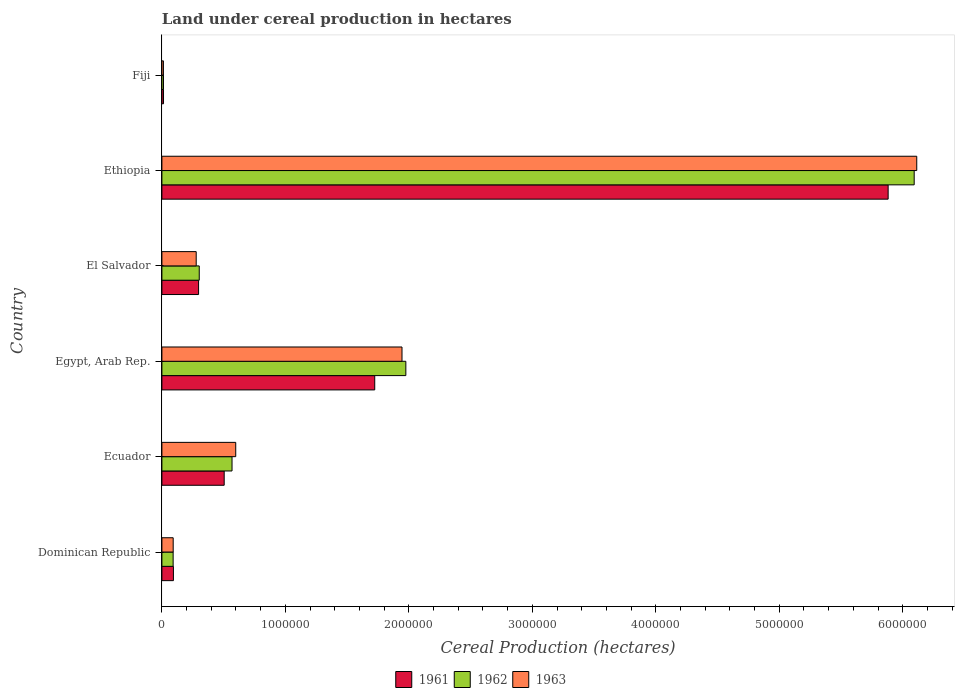How many different coloured bars are there?
Keep it short and to the point. 3. Are the number of bars per tick equal to the number of legend labels?
Make the answer very short. Yes. Are the number of bars on each tick of the Y-axis equal?
Offer a terse response. Yes. What is the label of the 5th group of bars from the top?
Keep it short and to the point. Ecuador. What is the land under cereal production in 1963 in Ecuador?
Offer a terse response. 5.98e+05. Across all countries, what is the maximum land under cereal production in 1962?
Your response must be concise. 6.09e+06. Across all countries, what is the minimum land under cereal production in 1961?
Ensure brevity in your answer.  1.31e+04. In which country was the land under cereal production in 1963 maximum?
Your answer should be compact. Ethiopia. In which country was the land under cereal production in 1961 minimum?
Give a very brief answer. Fiji. What is the total land under cereal production in 1962 in the graph?
Make the answer very short. 9.04e+06. What is the difference between the land under cereal production in 1962 in Egypt, Arab Rep. and that in Fiji?
Provide a succinct answer. 1.96e+06. What is the difference between the land under cereal production in 1962 in El Salvador and the land under cereal production in 1961 in Egypt, Arab Rep.?
Make the answer very short. -1.42e+06. What is the average land under cereal production in 1963 per country?
Offer a terse response. 1.51e+06. What is the difference between the land under cereal production in 1962 and land under cereal production in 1963 in Fiji?
Offer a terse response. 594. What is the ratio of the land under cereal production in 1963 in Ecuador to that in Fiji?
Keep it short and to the point. 48.77. Is the difference between the land under cereal production in 1962 in El Salvador and Ethiopia greater than the difference between the land under cereal production in 1963 in El Salvador and Ethiopia?
Your answer should be compact. Yes. What is the difference between the highest and the second highest land under cereal production in 1962?
Make the answer very short. 4.12e+06. What is the difference between the highest and the lowest land under cereal production in 1962?
Your answer should be compact. 6.08e+06. Is the sum of the land under cereal production in 1963 in Dominican Republic and Ecuador greater than the maximum land under cereal production in 1961 across all countries?
Make the answer very short. No. What does the 3rd bar from the bottom in Dominican Republic represents?
Offer a very short reply. 1963. Are all the bars in the graph horizontal?
Offer a terse response. Yes. Does the graph contain grids?
Ensure brevity in your answer.  No. How are the legend labels stacked?
Keep it short and to the point. Horizontal. What is the title of the graph?
Offer a terse response. Land under cereal production in hectares. What is the label or title of the X-axis?
Make the answer very short. Cereal Production (hectares). What is the Cereal Production (hectares) in 1961 in Dominican Republic?
Offer a very short reply. 9.33e+04. What is the Cereal Production (hectares) of 1962 in Dominican Republic?
Your response must be concise. 9.10e+04. What is the Cereal Production (hectares) in 1963 in Dominican Republic?
Offer a very short reply. 9.14e+04. What is the Cereal Production (hectares) in 1961 in Ecuador?
Ensure brevity in your answer.  5.05e+05. What is the Cereal Production (hectares) in 1962 in Ecuador?
Offer a very short reply. 5.68e+05. What is the Cereal Production (hectares) in 1963 in Ecuador?
Offer a terse response. 5.98e+05. What is the Cereal Production (hectares) of 1961 in Egypt, Arab Rep.?
Your answer should be very brief. 1.72e+06. What is the Cereal Production (hectares) of 1962 in Egypt, Arab Rep.?
Your answer should be compact. 1.98e+06. What is the Cereal Production (hectares) in 1963 in Egypt, Arab Rep.?
Your answer should be compact. 1.94e+06. What is the Cereal Production (hectares) of 1961 in El Salvador?
Give a very brief answer. 2.97e+05. What is the Cereal Production (hectares) in 1962 in El Salvador?
Your response must be concise. 3.02e+05. What is the Cereal Production (hectares) in 1963 in El Salvador?
Give a very brief answer. 2.78e+05. What is the Cereal Production (hectares) in 1961 in Ethiopia?
Make the answer very short. 5.88e+06. What is the Cereal Production (hectares) of 1962 in Ethiopia?
Keep it short and to the point. 6.09e+06. What is the Cereal Production (hectares) of 1963 in Ethiopia?
Make the answer very short. 6.11e+06. What is the Cereal Production (hectares) of 1961 in Fiji?
Provide a short and direct response. 1.31e+04. What is the Cereal Production (hectares) of 1962 in Fiji?
Provide a succinct answer. 1.29e+04. What is the Cereal Production (hectares) of 1963 in Fiji?
Make the answer very short. 1.23e+04. Across all countries, what is the maximum Cereal Production (hectares) of 1961?
Your answer should be compact. 5.88e+06. Across all countries, what is the maximum Cereal Production (hectares) in 1962?
Keep it short and to the point. 6.09e+06. Across all countries, what is the maximum Cereal Production (hectares) in 1963?
Make the answer very short. 6.11e+06. Across all countries, what is the minimum Cereal Production (hectares) of 1961?
Provide a succinct answer. 1.31e+04. Across all countries, what is the minimum Cereal Production (hectares) in 1962?
Your answer should be compact. 1.29e+04. Across all countries, what is the minimum Cereal Production (hectares) in 1963?
Keep it short and to the point. 1.23e+04. What is the total Cereal Production (hectares) in 1961 in the graph?
Your answer should be compact. 8.51e+06. What is the total Cereal Production (hectares) of 1962 in the graph?
Provide a short and direct response. 9.04e+06. What is the total Cereal Production (hectares) in 1963 in the graph?
Offer a terse response. 9.04e+06. What is the difference between the Cereal Production (hectares) of 1961 in Dominican Republic and that in Ecuador?
Offer a very short reply. -4.11e+05. What is the difference between the Cereal Production (hectares) of 1962 in Dominican Republic and that in Ecuador?
Offer a very short reply. -4.77e+05. What is the difference between the Cereal Production (hectares) of 1963 in Dominican Republic and that in Ecuador?
Offer a very short reply. -5.07e+05. What is the difference between the Cereal Production (hectares) in 1961 in Dominican Republic and that in Egypt, Arab Rep.?
Your answer should be compact. -1.63e+06. What is the difference between the Cereal Production (hectares) of 1962 in Dominican Republic and that in Egypt, Arab Rep.?
Your answer should be very brief. -1.88e+06. What is the difference between the Cereal Production (hectares) in 1963 in Dominican Republic and that in Egypt, Arab Rep.?
Your response must be concise. -1.85e+06. What is the difference between the Cereal Production (hectares) of 1961 in Dominican Republic and that in El Salvador?
Your answer should be compact. -2.04e+05. What is the difference between the Cereal Production (hectares) in 1962 in Dominican Republic and that in El Salvador?
Your answer should be very brief. -2.11e+05. What is the difference between the Cereal Production (hectares) in 1963 in Dominican Republic and that in El Salvador?
Offer a terse response. -1.86e+05. What is the difference between the Cereal Production (hectares) in 1961 in Dominican Republic and that in Ethiopia?
Give a very brief answer. -5.79e+06. What is the difference between the Cereal Production (hectares) of 1962 in Dominican Republic and that in Ethiopia?
Your response must be concise. -6.00e+06. What is the difference between the Cereal Production (hectares) of 1963 in Dominican Republic and that in Ethiopia?
Offer a terse response. -6.02e+06. What is the difference between the Cereal Production (hectares) of 1961 in Dominican Republic and that in Fiji?
Your answer should be very brief. 8.03e+04. What is the difference between the Cereal Production (hectares) in 1962 in Dominican Republic and that in Fiji?
Your response must be concise. 7.81e+04. What is the difference between the Cereal Production (hectares) in 1963 in Dominican Republic and that in Fiji?
Your answer should be very brief. 7.91e+04. What is the difference between the Cereal Production (hectares) of 1961 in Ecuador and that in Egypt, Arab Rep.?
Provide a short and direct response. -1.22e+06. What is the difference between the Cereal Production (hectares) in 1962 in Ecuador and that in Egypt, Arab Rep.?
Offer a terse response. -1.41e+06. What is the difference between the Cereal Production (hectares) in 1963 in Ecuador and that in Egypt, Arab Rep.?
Make the answer very short. -1.35e+06. What is the difference between the Cereal Production (hectares) of 1961 in Ecuador and that in El Salvador?
Offer a terse response. 2.07e+05. What is the difference between the Cereal Production (hectares) of 1962 in Ecuador and that in El Salvador?
Offer a very short reply. 2.66e+05. What is the difference between the Cereal Production (hectares) in 1963 in Ecuador and that in El Salvador?
Provide a succinct answer. 3.20e+05. What is the difference between the Cereal Production (hectares) of 1961 in Ecuador and that in Ethiopia?
Make the answer very short. -5.38e+06. What is the difference between the Cereal Production (hectares) in 1962 in Ecuador and that in Ethiopia?
Ensure brevity in your answer.  -5.53e+06. What is the difference between the Cereal Production (hectares) in 1963 in Ecuador and that in Ethiopia?
Your response must be concise. -5.52e+06. What is the difference between the Cereal Production (hectares) in 1961 in Ecuador and that in Fiji?
Keep it short and to the point. 4.91e+05. What is the difference between the Cereal Production (hectares) of 1962 in Ecuador and that in Fiji?
Ensure brevity in your answer.  5.55e+05. What is the difference between the Cereal Production (hectares) in 1963 in Ecuador and that in Fiji?
Keep it short and to the point. 5.86e+05. What is the difference between the Cereal Production (hectares) in 1961 in Egypt, Arab Rep. and that in El Salvador?
Offer a terse response. 1.43e+06. What is the difference between the Cereal Production (hectares) of 1962 in Egypt, Arab Rep. and that in El Salvador?
Your answer should be very brief. 1.67e+06. What is the difference between the Cereal Production (hectares) in 1963 in Egypt, Arab Rep. and that in El Salvador?
Ensure brevity in your answer.  1.67e+06. What is the difference between the Cereal Production (hectares) in 1961 in Egypt, Arab Rep. and that in Ethiopia?
Make the answer very short. -4.16e+06. What is the difference between the Cereal Production (hectares) of 1962 in Egypt, Arab Rep. and that in Ethiopia?
Provide a succinct answer. -4.12e+06. What is the difference between the Cereal Production (hectares) of 1963 in Egypt, Arab Rep. and that in Ethiopia?
Keep it short and to the point. -4.17e+06. What is the difference between the Cereal Production (hectares) of 1961 in Egypt, Arab Rep. and that in Fiji?
Your answer should be compact. 1.71e+06. What is the difference between the Cereal Production (hectares) of 1962 in Egypt, Arab Rep. and that in Fiji?
Keep it short and to the point. 1.96e+06. What is the difference between the Cereal Production (hectares) in 1963 in Egypt, Arab Rep. and that in Fiji?
Offer a very short reply. 1.93e+06. What is the difference between the Cereal Production (hectares) of 1961 in El Salvador and that in Ethiopia?
Offer a very short reply. -5.58e+06. What is the difference between the Cereal Production (hectares) in 1962 in El Salvador and that in Ethiopia?
Your answer should be very brief. -5.79e+06. What is the difference between the Cereal Production (hectares) in 1963 in El Salvador and that in Ethiopia?
Your response must be concise. -5.84e+06. What is the difference between the Cereal Production (hectares) of 1961 in El Salvador and that in Fiji?
Offer a terse response. 2.84e+05. What is the difference between the Cereal Production (hectares) of 1962 in El Salvador and that in Fiji?
Keep it short and to the point. 2.90e+05. What is the difference between the Cereal Production (hectares) of 1963 in El Salvador and that in Fiji?
Keep it short and to the point. 2.66e+05. What is the difference between the Cereal Production (hectares) of 1961 in Ethiopia and that in Fiji?
Your answer should be compact. 5.87e+06. What is the difference between the Cereal Production (hectares) of 1962 in Ethiopia and that in Fiji?
Give a very brief answer. 6.08e+06. What is the difference between the Cereal Production (hectares) in 1963 in Ethiopia and that in Fiji?
Keep it short and to the point. 6.10e+06. What is the difference between the Cereal Production (hectares) of 1961 in Dominican Republic and the Cereal Production (hectares) of 1962 in Ecuador?
Ensure brevity in your answer.  -4.75e+05. What is the difference between the Cereal Production (hectares) of 1961 in Dominican Republic and the Cereal Production (hectares) of 1963 in Ecuador?
Ensure brevity in your answer.  -5.05e+05. What is the difference between the Cereal Production (hectares) in 1962 in Dominican Republic and the Cereal Production (hectares) in 1963 in Ecuador?
Provide a succinct answer. -5.07e+05. What is the difference between the Cereal Production (hectares) in 1961 in Dominican Republic and the Cereal Production (hectares) in 1962 in Egypt, Arab Rep.?
Keep it short and to the point. -1.88e+06. What is the difference between the Cereal Production (hectares) in 1961 in Dominican Republic and the Cereal Production (hectares) in 1963 in Egypt, Arab Rep.?
Your response must be concise. -1.85e+06. What is the difference between the Cereal Production (hectares) in 1962 in Dominican Republic and the Cereal Production (hectares) in 1963 in Egypt, Arab Rep.?
Provide a short and direct response. -1.85e+06. What is the difference between the Cereal Production (hectares) of 1961 in Dominican Republic and the Cereal Production (hectares) of 1962 in El Salvador?
Your answer should be very brief. -2.09e+05. What is the difference between the Cereal Production (hectares) of 1961 in Dominican Republic and the Cereal Production (hectares) of 1963 in El Salvador?
Give a very brief answer. -1.85e+05. What is the difference between the Cereal Production (hectares) in 1962 in Dominican Republic and the Cereal Production (hectares) in 1963 in El Salvador?
Your answer should be compact. -1.87e+05. What is the difference between the Cereal Production (hectares) in 1961 in Dominican Republic and the Cereal Production (hectares) in 1962 in Ethiopia?
Make the answer very short. -6.00e+06. What is the difference between the Cereal Production (hectares) of 1961 in Dominican Republic and the Cereal Production (hectares) of 1963 in Ethiopia?
Your answer should be compact. -6.02e+06. What is the difference between the Cereal Production (hectares) of 1962 in Dominican Republic and the Cereal Production (hectares) of 1963 in Ethiopia?
Offer a very short reply. -6.02e+06. What is the difference between the Cereal Production (hectares) in 1961 in Dominican Republic and the Cereal Production (hectares) in 1962 in Fiji?
Your answer should be very brief. 8.05e+04. What is the difference between the Cereal Production (hectares) in 1961 in Dominican Republic and the Cereal Production (hectares) in 1963 in Fiji?
Keep it short and to the point. 8.11e+04. What is the difference between the Cereal Production (hectares) in 1962 in Dominican Republic and the Cereal Production (hectares) in 1963 in Fiji?
Make the answer very short. 7.87e+04. What is the difference between the Cereal Production (hectares) in 1961 in Ecuador and the Cereal Production (hectares) in 1962 in Egypt, Arab Rep.?
Make the answer very short. -1.47e+06. What is the difference between the Cereal Production (hectares) of 1961 in Ecuador and the Cereal Production (hectares) of 1963 in Egypt, Arab Rep.?
Provide a short and direct response. -1.44e+06. What is the difference between the Cereal Production (hectares) of 1962 in Ecuador and the Cereal Production (hectares) of 1963 in Egypt, Arab Rep.?
Provide a succinct answer. -1.38e+06. What is the difference between the Cereal Production (hectares) of 1961 in Ecuador and the Cereal Production (hectares) of 1962 in El Salvador?
Provide a succinct answer. 2.02e+05. What is the difference between the Cereal Production (hectares) in 1961 in Ecuador and the Cereal Production (hectares) in 1963 in El Salvador?
Give a very brief answer. 2.27e+05. What is the difference between the Cereal Production (hectares) in 1962 in Ecuador and the Cereal Production (hectares) in 1963 in El Salvador?
Your answer should be compact. 2.90e+05. What is the difference between the Cereal Production (hectares) in 1961 in Ecuador and the Cereal Production (hectares) in 1962 in Ethiopia?
Offer a terse response. -5.59e+06. What is the difference between the Cereal Production (hectares) in 1961 in Ecuador and the Cereal Production (hectares) in 1963 in Ethiopia?
Offer a very short reply. -5.61e+06. What is the difference between the Cereal Production (hectares) in 1962 in Ecuador and the Cereal Production (hectares) in 1963 in Ethiopia?
Offer a terse response. -5.55e+06. What is the difference between the Cereal Production (hectares) in 1961 in Ecuador and the Cereal Production (hectares) in 1962 in Fiji?
Keep it short and to the point. 4.92e+05. What is the difference between the Cereal Production (hectares) in 1961 in Ecuador and the Cereal Production (hectares) in 1963 in Fiji?
Ensure brevity in your answer.  4.92e+05. What is the difference between the Cereal Production (hectares) of 1962 in Ecuador and the Cereal Production (hectares) of 1963 in Fiji?
Offer a very short reply. 5.56e+05. What is the difference between the Cereal Production (hectares) of 1961 in Egypt, Arab Rep. and the Cereal Production (hectares) of 1962 in El Salvador?
Offer a terse response. 1.42e+06. What is the difference between the Cereal Production (hectares) in 1961 in Egypt, Arab Rep. and the Cereal Production (hectares) in 1963 in El Salvador?
Make the answer very short. 1.45e+06. What is the difference between the Cereal Production (hectares) in 1962 in Egypt, Arab Rep. and the Cereal Production (hectares) in 1963 in El Salvador?
Offer a terse response. 1.70e+06. What is the difference between the Cereal Production (hectares) of 1961 in Egypt, Arab Rep. and the Cereal Production (hectares) of 1962 in Ethiopia?
Keep it short and to the point. -4.37e+06. What is the difference between the Cereal Production (hectares) of 1961 in Egypt, Arab Rep. and the Cereal Production (hectares) of 1963 in Ethiopia?
Offer a terse response. -4.39e+06. What is the difference between the Cereal Production (hectares) in 1962 in Egypt, Arab Rep. and the Cereal Production (hectares) in 1963 in Ethiopia?
Give a very brief answer. -4.14e+06. What is the difference between the Cereal Production (hectares) of 1961 in Egypt, Arab Rep. and the Cereal Production (hectares) of 1962 in Fiji?
Your answer should be compact. 1.71e+06. What is the difference between the Cereal Production (hectares) in 1961 in Egypt, Arab Rep. and the Cereal Production (hectares) in 1963 in Fiji?
Your response must be concise. 1.71e+06. What is the difference between the Cereal Production (hectares) in 1962 in Egypt, Arab Rep. and the Cereal Production (hectares) in 1963 in Fiji?
Make the answer very short. 1.96e+06. What is the difference between the Cereal Production (hectares) in 1961 in El Salvador and the Cereal Production (hectares) in 1962 in Ethiopia?
Offer a terse response. -5.80e+06. What is the difference between the Cereal Production (hectares) in 1961 in El Salvador and the Cereal Production (hectares) in 1963 in Ethiopia?
Make the answer very short. -5.82e+06. What is the difference between the Cereal Production (hectares) in 1962 in El Salvador and the Cereal Production (hectares) in 1963 in Ethiopia?
Your response must be concise. -5.81e+06. What is the difference between the Cereal Production (hectares) of 1961 in El Salvador and the Cereal Production (hectares) of 1962 in Fiji?
Your answer should be very brief. 2.84e+05. What is the difference between the Cereal Production (hectares) in 1961 in El Salvador and the Cereal Production (hectares) in 1963 in Fiji?
Your answer should be compact. 2.85e+05. What is the difference between the Cereal Production (hectares) in 1962 in El Salvador and the Cereal Production (hectares) in 1963 in Fiji?
Ensure brevity in your answer.  2.90e+05. What is the difference between the Cereal Production (hectares) of 1961 in Ethiopia and the Cereal Production (hectares) of 1962 in Fiji?
Your answer should be very brief. 5.87e+06. What is the difference between the Cereal Production (hectares) of 1961 in Ethiopia and the Cereal Production (hectares) of 1963 in Fiji?
Offer a very short reply. 5.87e+06. What is the difference between the Cereal Production (hectares) of 1962 in Ethiopia and the Cereal Production (hectares) of 1963 in Fiji?
Make the answer very short. 6.08e+06. What is the average Cereal Production (hectares) in 1961 per country?
Offer a very short reply. 1.42e+06. What is the average Cereal Production (hectares) of 1962 per country?
Keep it short and to the point. 1.51e+06. What is the average Cereal Production (hectares) of 1963 per country?
Offer a very short reply. 1.51e+06. What is the difference between the Cereal Production (hectares) of 1961 and Cereal Production (hectares) of 1962 in Dominican Republic?
Ensure brevity in your answer.  2320. What is the difference between the Cereal Production (hectares) of 1961 and Cereal Production (hectares) of 1963 in Dominican Republic?
Your response must be concise. 1920. What is the difference between the Cereal Production (hectares) in 1962 and Cereal Production (hectares) in 1963 in Dominican Republic?
Your answer should be very brief. -400. What is the difference between the Cereal Production (hectares) of 1961 and Cereal Production (hectares) of 1962 in Ecuador?
Keep it short and to the point. -6.34e+04. What is the difference between the Cereal Production (hectares) of 1961 and Cereal Production (hectares) of 1963 in Ecuador?
Offer a very short reply. -9.35e+04. What is the difference between the Cereal Production (hectares) of 1962 and Cereal Production (hectares) of 1963 in Ecuador?
Your response must be concise. -3.01e+04. What is the difference between the Cereal Production (hectares) in 1961 and Cereal Production (hectares) in 1962 in Egypt, Arab Rep.?
Your answer should be very brief. -2.52e+05. What is the difference between the Cereal Production (hectares) of 1961 and Cereal Production (hectares) of 1963 in Egypt, Arab Rep.?
Offer a very short reply. -2.21e+05. What is the difference between the Cereal Production (hectares) of 1962 and Cereal Production (hectares) of 1963 in Egypt, Arab Rep.?
Offer a very short reply. 3.10e+04. What is the difference between the Cereal Production (hectares) of 1961 and Cereal Production (hectares) of 1962 in El Salvador?
Provide a succinct answer. -5375. What is the difference between the Cereal Production (hectares) of 1961 and Cereal Production (hectares) of 1963 in El Salvador?
Your answer should be very brief. 1.92e+04. What is the difference between the Cereal Production (hectares) of 1962 and Cereal Production (hectares) of 1963 in El Salvador?
Keep it short and to the point. 2.46e+04. What is the difference between the Cereal Production (hectares) in 1961 and Cereal Production (hectares) in 1962 in Ethiopia?
Give a very brief answer. -2.11e+05. What is the difference between the Cereal Production (hectares) in 1961 and Cereal Production (hectares) in 1963 in Ethiopia?
Provide a short and direct response. -2.32e+05. What is the difference between the Cereal Production (hectares) in 1962 and Cereal Production (hectares) in 1963 in Ethiopia?
Give a very brief answer. -2.07e+04. What is the difference between the Cereal Production (hectares) in 1961 and Cereal Production (hectares) in 1962 in Fiji?
Your answer should be compact. 203. What is the difference between the Cereal Production (hectares) of 1961 and Cereal Production (hectares) of 1963 in Fiji?
Keep it short and to the point. 797. What is the difference between the Cereal Production (hectares) of 1962 and Cereal Production (hectares) of 1963 in Fiji?
Give a very brief answer. 594. What is the ratio of the Cereal Production (hectares) in 1961 in Dominican Republic to that in Ecuador?
Give a very brief answer. 0.18. What is the ratio of the Cereal Production (hectares) of 1962 in Dominican Republic to that in Ecuador?
Provide a succinct answer. 0.16. What is the ratio of the Cereal Production (hectares) of 1963 in Dominican Republic to that in Ecuador?
Provide a succinct answer. 0.15. What is the ratio of the Cereal Production (hectares) in 1961 in Dominican Republic to that in Egypt, Arab Rep.?
Make the answer very short. 0.05. What is the ratio of the Cereal Production (hectares) in 1962 in Dominican Republic to that in Egypt, Arab Rep.?
Ensure brevity in your answer.  0.05. What is the ratio of the Cereal Production (hectares) of 1963 in Dominican Republic to that in Egypt, Arab Rep.?
Offer a terse response. 0.05. What is the ratio of the Cereal Production (hectares) in 1961 in Dominican Republic to that in El Salvador?
Your answer should be very brief. 0.31. What is the ratio of the Cereal Production (hectares) in 1962 in Dominican Republic to that in El Salvador?
Offer a very short reply. 0.3. What is the ratio of the Cereal Production (hectares) in 1963 in Dominican Republic to that in El Salvador?
Provide a succinct answer. 0.33. What is the ratio of the Cereal Production (hectares) of 1961 in Dominican Republic to that in Ethiopia?
Provide a short and direct response. 0.02. What is the ratio of the Cereal Production (hectares) of 1962 in Dominican Republic to that in Ethiopia?
Your answer should be very brief. 0.01. What is the ratio of the Cereal Production (hectares) of 1963 in Dominican Republic to that in Ethiopia?
Give a very brief answer. 0.01. What is the ratio of the Cereal Production (hectares) of 1961 in Dominican Republic to that in Fiji?
Offer a very short reply. 7.15. What is the ratio of the Cereal Production (hectares) in 1962 in Dominican Republic to that in Fiji?
Offer a very short reply. 7.08. What is the ratio of the Cereal Production (hectares) of 1963 in Dominican Republic to that in Fiji?
Your response must be concise. 7.45. What is the ratio of the Cereal Production (hectares) of 1961 in Ecuador to that in Egypt, Arab Rep.?
Give a very brief answer. 0.29. What is the ratio of the Cereal Production (hectares) in 1962 in Ecuador to that in Egypt, Arab Rep.?
Provide a short and direct response. 0.29. What is the ratio of the Cereal Production (hectares) in 1963 in Ecuador to that in Egypt, Arab Rep.?
Your response must be concise. 0.31. What is the ratio of the Cereal Production (hectares) of 1961 in Ecuador to that in El Salvador?
Give a very brief answer. 1.7. What is the ratio of the Cereal Production (hectares) in 1962 in Ecuador to that in El Salvador?
Make the answer very short. 1.88. What is the ratio of the Cereal Production (hectares) in 1963 in Ecuador to that in El Salvador?
Make the answer very short. 2.15. What is the ratio of the Cereal Production (hectares) in 1961 in Ecuador to that in Ethiopia?
Keep it short and to the point. 0.09. What is the ratio of the Cereal Production (hectares) in 1962 in Ecuador to that in Ethiopia?
Your response must be concise. 0.09. What is the ratio of the Cereal Production (hectares) of 1963 in Ecuador to that in Ethiopia?
Ensure brevity in your answer.  0.1. What is the ratio of the Cereal Production (hectares) of 1961 in Ecuador to that in Fiji?
Provide a succinct answer. 38.63. What is the ratio of the Cereal Production (hectares) of 1962 in Ecuador to that in Fiji?
Ensure brevity in your answer.  44.18. What is the ratio of the Cereal Production (hectares) in 1963 in Ecuador to that in Fiji?
Ensure brevity in your answer.  48.77. What is the ratio of the Cereal Production (hectares) in 1961 in Egypt, Arab Rep. to that in El Salvador?
Offer a terse response. 5.8. What is the ratio of the Cereal Production (hectares) of 1962 in Egypt, Arab Rep. to that in El Salvador?
Provide a succinct answer. 6.53. What is the ratio of the Cereal Production (hectares) in 1963 in Egypt, Arab Rep. to that in El Salvador?
Offer a terse response. 7. What is the ratio of the Cereal Production (hectares) of 1961 in Egypt, Arab Rep. to that in Ethiopia?
Your answer should be compact. 0.29. What is the ratio of the Cereal Production (hectares) in 1962 in Egypt, Arab Rep. to that in Ethiopia?
Your response must be concise. 0.32. What is the ratio of the Cereal Production (hectares) in 1963 in Egypt, Arab Rep. to that in Ethiopia?
Offer a very short reply. 0.32. What is the ratio of the Cereal Production (hectares) in 1961 in Egypt, Arab Rep. to that in Fiji?
Offer a terse response. 131.99. What is the ratio of the Cereal Production (hectares) in 1962 in Egypt, Arab Rep. to that in Fiji?
Your response must be concise. 153.67. What is the ratio of the Cereal Production (hectares) of 1963 in Egypt, Arab Rep. to that in Fiji?
Keep it short and to the point. 158.58. What is the ratio of the Cereal Production (hectares) of 1961 in El Salvador to that in Ethiopia?
Make the answer very short. 0.05. What is the ratio of the Cereal Production (hectares) in 1962 in El Salvador to that in Ethiopia?
Make the answer very short. 0.05. What is the ratio of the Cereal Production (hectares) in 1963 in El Salvador to that in Ethiopia?
Your answer should be compact. 0.05. What is the ratio of the Cereal Production (hectares) in 1961 in El Salvador to that in Fiji?
Offer a terse response. 22.75. What is the ratio of the Cereal Production (hectares) in 1962 in El Salvador to that in Fiji?
Keep it short and to the point. 23.53. What is the ratio of the Cereal Production (hectares) in 1963 in El Salvador to that in Fiji?
Offer a very short reply. 22.66. What is the ratio of the Cereal Production (hectares) in 1961 in Ethiopia to that in Fiji?
Keep it short and to the point. 450.38. What is the ratio of the Cereal Production (hectares) of 1962 in Ethiopia to that in Fiji?
Provide a short and direct response. 473.91. What is the ratio of the Cereal Production (hectares) in 1963 in Ethiopia to that in Fiji?
Provide a short and direct response. 498.55. What is the difference between the highest and the second highest Cereal Production (hectares) in 1961?
Give a very brief answer. 4.16e+06. What is the difference between the highest and the second highest Cereal Production (hectares) in 1962?
Ensure brevity in your answer.  4.12e+06. What is the difference between the highest and the second highest Cereal Production (hectares) in 1963?
Keep it short and to the point. 4.17e+06. What is the difference between the highest and the lowest Cereal Production (hectares) in 1961?
Provide a short and direct response. 5.87e+06. What is the difference between the highest and the lowest Cereal Production (hectares) in 1962?
Ensure brevity in your answer.  6.08e+06. What is the difference between the highest and the lowest Cereal Production (hectares) in 1963?
Keep it short and to the point. 6.10e+06. 